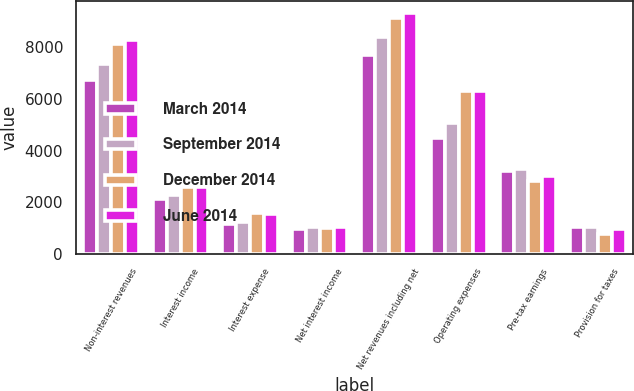Convert chart to OTSL. <chart><loc_0><loc_0><loc_500><loc_500><stacked_bar_chart><ecel><fcel>Non-interest revenues<fcel>Interest income<fcel>Interest expense<fcel>Net interest income<fcel>Net revenues including net<fcel>Operating expenses<fcel>Pre-tax earnings<fcel>Provision for taxes<nl><fcel>March 2014<fcel>6727<fcel>2134<fcel>1173<fcel>961<fcel>7688<fcel>4478<fcel>3210<fcel>1044<nl><fcel>September 2014<fcel>7338<fcel>2297<fcel>1248<fcel>1049<fcel>8387<fcel>5082<fcel>3305<fcel>1064<nl><fcel>December 2014<fcel>8125<fcel>2579<fcel>1579<fcel>1000<fcel>9125<fcel>6304<fcel>2821<fcel>784<nl><fcel>June 2014<fcel>8291<fcel>2594<fcel>1557<fcel>1037<fcel>9328<fcel>6307<fcel>3021<fcel>988<nl></chart> 